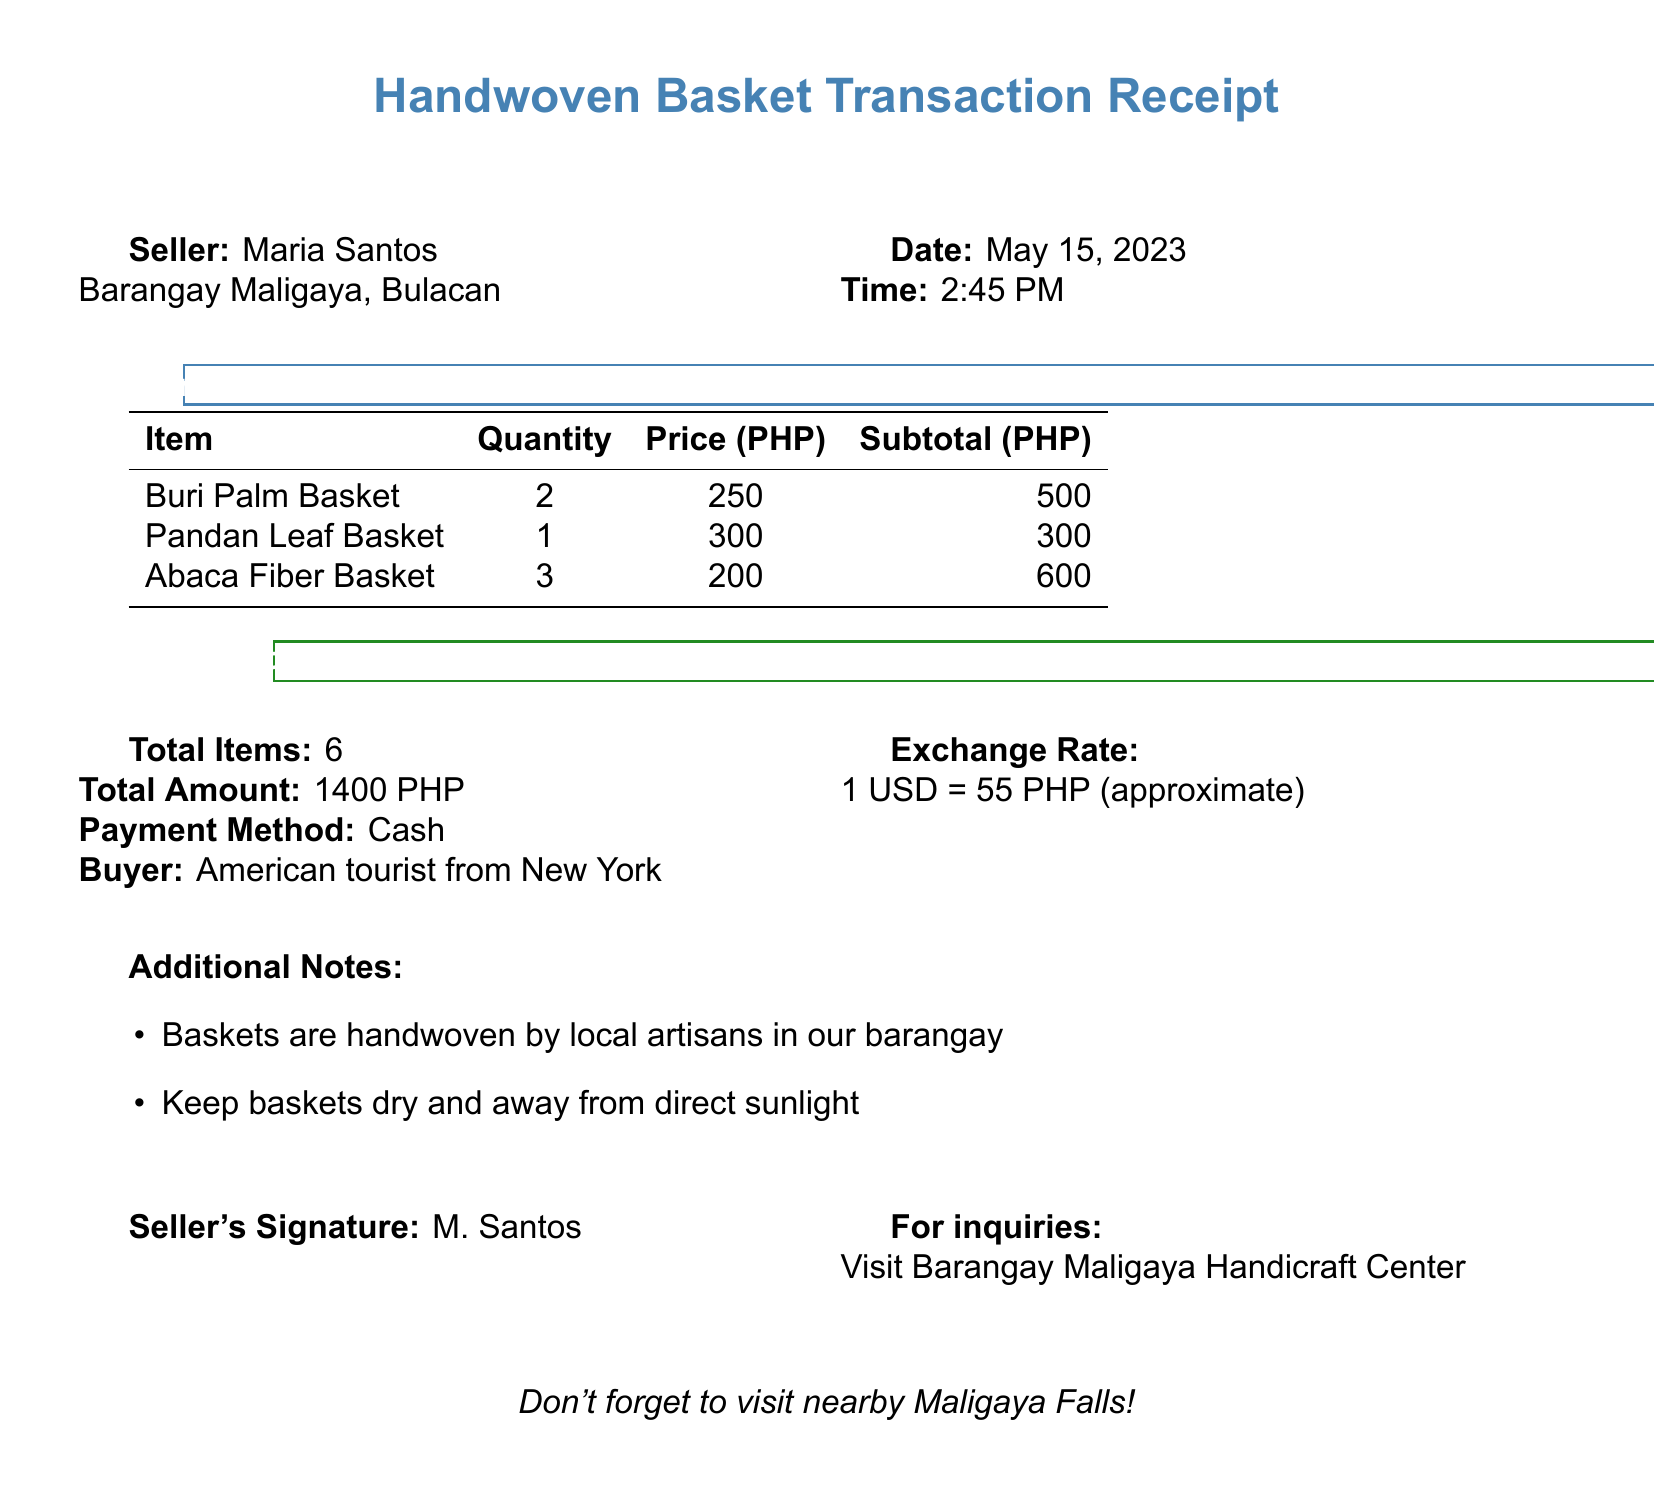What is the seller's name? The seller's name is explicitly stated at the top of the transaction receipt.
Answer: Maria Santos What is the total amount received? The total amount received is summarized in the transaction summary section of the document.
Answer: 1400 PHP Who is the buyer? The document describes the buyer in the transaction summary section.
Answer: American tourist from New York How many items were sold in total? The total number of items sold is indicated in the document for easy reference.
Answer: 6 What is the price of the Pandan Leaf Basket? The price of the Pandan Leaf Basket is listed in the items sold table.
Answer: 300 What payment method was used? The payment method for the transaction is mentioned in the transaction summary section.
Answer: Cash What is the location of the seller? The seller's location is provided at the top of the receipt.
Answer: Barangay Maligaya, Bulacan What is the exchange rate mentioned? The exchange rate is included in the transaction summary for reference.
Answer: 1 USD = 55 PHP (approximate) What is included in the additional notes? The additional notes contain insights related to the product care and origin.
Answer: Baskets are handwoven by local artisans in our barangay 